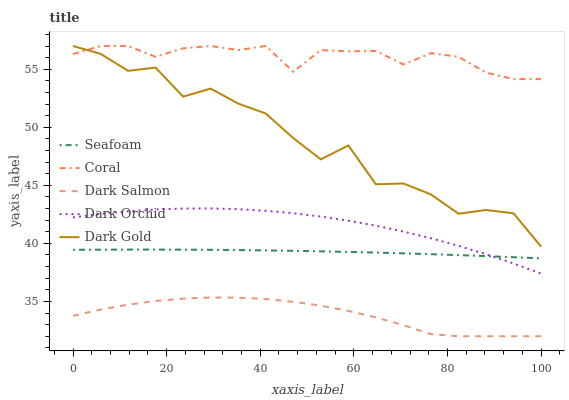Does Dark Salmon have the minimum area under the curve?
Answer yes or no. Yes. Does Coral have the maximum area under the curve?
Answer yes or no. Yes. Does Dark Gold have the minimum area under the curve?
Answer yes or no. No. Does Dark Gold have the maximum area under the curve?
Answer yes or no. No. Is Seafoam the smoothest?
Answer yes or no. Yes. Is Dark Gold the roughest?
Answer yes or no. Yes. Is Dark Gold the smoothest?
Answer yes or no. No. Is Seafoam the roughest?
Answer yes or no. No. Does Dark Salmon have the lowest value?
Answer yes or no. Yes. Does Dark Gold have the lowest value?
Answer yes or no. No. Does Dark Gold have the highest value?
Answer yes or no. Yes. Does Seafoam have the highest value?
Answer yes or no. No. Is Dark Salmon less than Dark Orchid?
Answer yes or no. Yes. Is Dark Orchid greater than Dark Salmon?
Answer yes or no. Yes. Does Dark Orchid intersect Seafoam?
Answer yes or no. Yes. Is Dark Orchid less than Seafoam?
Answer yes or no. No. Is Dark Orchid greater than Seafoam?
Answer yes or no. No. Does Dark Salmon intersect Dark Orchid?
Answer yes or no. No. 